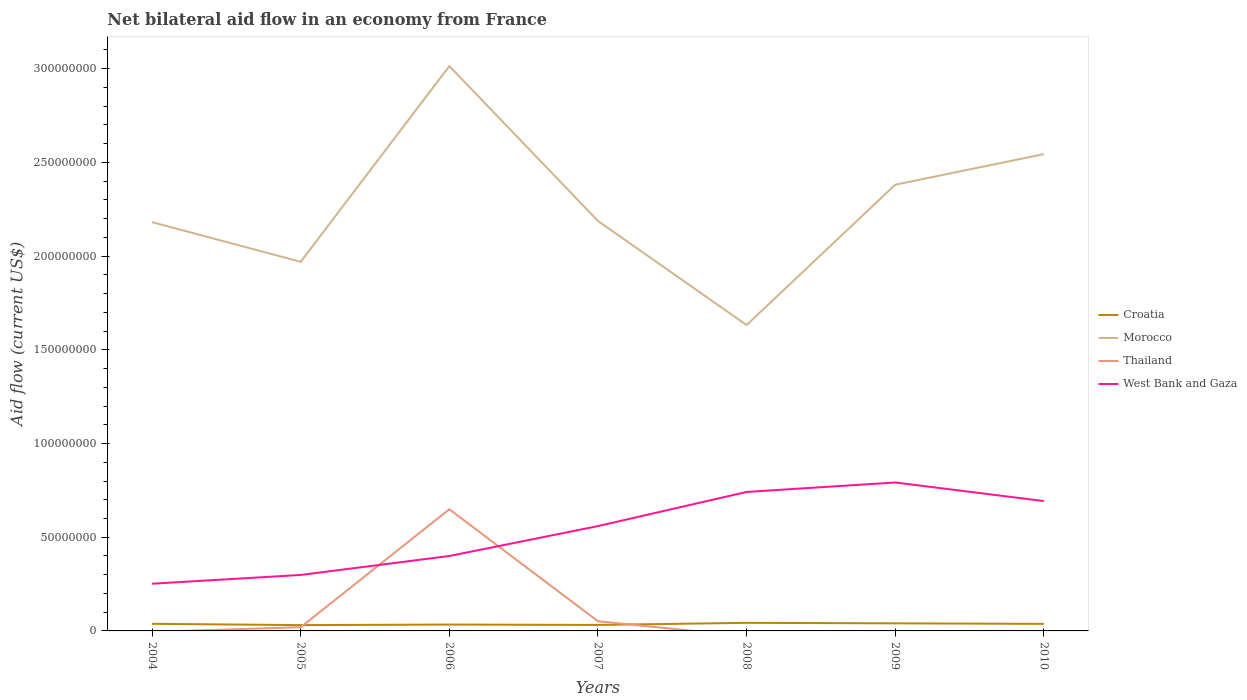How many different coloured lines are there?
Provide a succinct answer. 4. Does the line corresponding to West Bank and Gaza intersect with the line corresponding to Croatia?
Offer a terse response. No. Across all years, what is the maximum net bilateral aid flow in West Bank and Gaza?
Make the answer very short. 2.52e+07. What is the total net bilateral aid flow in West Bank and Gaza in the graph?
Ensure brevity in your answer.  -4.68e+06. What is the difference between the highest and the second highest net bilateral aid flow in Croatia?
Make the answer very short. 1.22e+06. How many years are there in the graph?
Provide a succinct answer. 7. What is the difference between two consecutive major ticks on the Y-axis?
Provide a succinct answer. 5.00e+07. Where does the legend appear in the graph?
Offer a terse response. Center right. What is the title of the graph?
Your answer should be very brief. Net bilateral aid flow in an economy from France. What is the label or title of the X-axis?
Give a very brief answer. Years. What is the Aid flow (current US$) of Croatia in 2004?
Offer a terse response. 3.79e+06. What is the Aid flow (current US$) in Morocco in 2004?
Ensure brevity in your answer.  2.18e+08. What is the Aid flow (current US$) in West Bank and Gaza in 2004?
Ensure brevity in your answer.  2.52e+07. What is the Aid flow (current US$) in Croatia in 2005?
Make the answer very short. 3.10e+06. What is the Aid flow (current US$) of Morocco in 2005?
Your answer should be very brief. 1.97e+08. What is the Aid flow (current US$) of Thailand in 2005?
Offer a terse response. 1.99e+06. What is the Aid flow (current US$) in West Bank and Gaza in 2005?
Your response must be concise. 2.99e+07. What is the Aid flow (current US$) in Croatia in 2006?
Offer a terse response. 3.39e+06. What is the Aid flow (current US$) in Morocco in 2006?
Your answer should be compact. 3.01e+08. What is the Aid flow (current US$) of Thailand in 2006?
Provide a succinct answer. 6.49e+07. What is the Aid flow (current US$) in West Bank and Gaza in 2006?
Your response must be concise. 4.00e+07. What is the Aid flow (current US$) of Croatia in 2007?
Your answer should be very brief. 3.19e+06. What is the Aid flow (current US$) in Morocco in 2007?
Your response must be concise. 2.19e+08. What is the Aid flow (current US$) of Thailand in 2007?
Give a very brief answer. 5.16e+06. What is the Aid flow (current US$) in West Bank and Gaza in 2007?
Your answer should be compact. 5.59e+07. What is the Aid flow (current US$) of Croatia in 2008?
Ensure brevity in your answer.  4.32e+06. What is the Aid flow (current US$) of Morocco in 2008?
Ensure brevity in your answer.  1.63e+08. What is the Aid flow (current US$) in Thailand in 2008?
Make the answer very short. 0. What is the Aid flow (current US$) in West Bank and Gaza in 2008?
Your answer should be compact. 7.42e+07. What is the Aid flow (current US$) of Croatia in 2009?
Give a very brief answer. 4.04e+06. What is the Aid flow (current US$) in Morocco in 2009?
Your answer should be compact. 2.38e+08. What is the Aid flow (current US$) in West Bank and Gaza in 2009?
Offer a terse response. 7.92e+07. What is the Aid flow (current US$) of Croatia in 2010?
Your response must be concise. 3.77e+06. What is the Aid flow (current US$) of Morocco in 2010?
Provide a short and direct response. 2.54e+08. What is the Aid flow (current US$) in Thailand in 2010?
Offer a terse response. 0. What is the Aid flow (current US$) in West Bank and Gaza in 2010?
Give a very brief answer. 6.93e+07. Across all years, what is the maximum Aid flow (current US$) in Croatia?
Keep it short and to the point. 4.32e+06. Across all years, what is the maximum Aid flow (current US$) in Morocco?
Keep it short and to the point. 3.01e+08. Across all years, what is the maximum Aid flow (current US$) in Thailand?
Your answer should be very brief. 6.49e+07. Across all years, what is the maximum Aid flow (current US$) of West Bank and Gaza?
Provide a succinct answer. 7.92e+07. Across all years, what is the minimum Aid flow (current US$) of Croatia?
Your answer should be compact. 3.10e+06. Across all years, what is the minimum Aid flow (current US$) of Morocco?
Keep it short and to the point. 1.63e+08. Across all years, what is the minimum Aid flow (current US$) in West Bank and Gaza?
Offer a terse response. 2.52e+07. What is the total Aid flow (current US$) of Croatia in the graph?
Make the answer very short. 2.56e+07. What is the total Aid flow (current US$) in Morocco in the graph?
Your answer should be compact. 1.59e+09. What is the total Aid flow (current US$) in Thailand in the graph?
Offer a terse response. 7.21e+07. What is the total Aid flow (current US$) of West Bank and Gaza in the graph?
Give a very brief answer. 3.74e+08. What is the difference between the Aid flow (current US$) of Croatia in 2004 and that in 2005?
Make the answer very short. 6.90e+05. What is the difference between the Aid flow (current US$) in Morocco in 2004 and that in 2005?
Your answer should be very brief. 2.11e+07. What is the difference between the Aid flow (current US$) in West Bank and Gaza in 2004 and that in 2005?
Offer a very short reply. -4.68e+06. What is the difference between the Aid flow (current US$) in Morocco in 2004 and that in 2006?
Give a very brief answer. -8.33e+07. What is the difference between the Aid flow (current US$) in West Bank and Gaza in 2004 and that in 2006?
Your response must be concise. -1.48e+07. What is the difference between the Aid flow (current US$) in Croatia in 2004 and that in 2007?
Ensure brevity in your answer.  6.00e+05. What is the difference between the Aid flow (current US$) in Morocco in 2004 and that in 2007?
Ensure brevity in your answer.  -6.50e+05. What is the difference between the Aid flow (current US$) of West Bank and Gaza in 2004 and that in 2007?
Your response must be concise. -3.07e+07. What is the difference between the Aid flow (current US$) in Croatia in 2004 and that in 2008?
Give a very brief answer. -5.30e+05. What is the difference between the Aid flow (current US$) in Morocco in 2004 and that in 2008?
Offer a terse response. 5.49e+07. What is the difference between the Aid flow (current US$) in West Bank and Gaza in 2004 and that in 2008?
Offer a terse response. -4.90e+07. What is the difference between the Aid flow (current US$) of Morocco in 2004 and that in 2009?
Provide a short and direct response. -2.00e+07. What is the difference between the Aid flow (current US$) in West Bank and Gaza in 2004 and that in 2009?
Your answer should be compact. -5.40e+07. What is the difference between the Aid flow (current US$) of Morocco in 2004 and that in 2010?
Ensure brevity in your answer.  -3.63e+07. What is the difference between the Aid flow (current US$) of West Bank and Gaza in 2004 and that in 2010?
Offer a very short reply. -4.41e+07. What is the difference between the Aid flow (current US$) of Morocco in 2005 and that in 2006?
Your response must be concise. -1.04e+08. What is the difference between the Aid flow (current US$) in Thailand in 2005 and that in 2006?
Ensure brevity in your answer.  -6.29e+07. What is the difference between the Aid flow (current US$) in West Bank and Gaza in 2005 and that in 2006?
Give a very brief answer. -1.01e+07. What is the difference between the Aid flow (current US$) of Morocco in 2005 and that in 2007?
Ensure brevity in your answer.  -2.18e+07. What is the difference between the Aid flow (current US$) of Thailand in 2005 and that in 2007?
Offer a terse response. -3.17e+06. What is the difference between the Aid flow (current US$) of West Bank and Gaza in 2005 and that in 2007?
Your answer should be compact. -2.61e+07. What is the difference between the Aid flow (current US$) of Croatia in 2005 and that in 2008?
Your answer should be very brief. -1.22e+06. What is the difference between the Aid flow (current US$) in Morocco in 2005 and that in 2008?
Make the answer very short. 3.38e+07. What is the difference between the Aid flow (current US$) of West Bank and Gaza in 2005 and that in 2008?
Your answer should be very brief. -4.43e+07. What is the difference between the Aid flow (current US$) in Croatia in 2005 and that in 2009?
Your response must be concise. -9.40e+05. What is the difference between the Aid flow (current US$) of Morocco in 2005 and that in 2009?
Provide a succinct answer. -4.11e+07. What is the difference between the Aid flow (current US$) of West Bank and Gaza in 2005 and that in 2009?
Ensure brevity in your answer.  -4.93e+07. What is the difference between the Aid flow (current US$) in Croatia in 2005 and that in 2010?
Provide a succinct answer. -6.70e+05. What is the difference between the Aid flow (current US$) of Morocco in 2005 and that in 2010?
Provide a succinct answer. -5.74e+07. What is the difference between the Aid flow (current US$) in West Bank and Gaza in 2005 and that in 2010?
Provide a short and direct response. -3.94e+07. What is the difference between the Aid flow (current US$) in Morocco in 2006 and that in 2007?
Your response must be concise. 8.26e+07. What is the difference between the Aid flow (current US$) of Thailand in 2006 and that in 2007?
Keep it short and to the point. 5.98e+07. What is the difference between the Aid flow (current US$) of West Bank and Gaza in 2006 and that in 2007?
Give a very brief answer. -1.60e+07. What is the difference between the Aid flow (current US$) of Croatia in 2006 and that in 2008?
Ensure brevity in your answer.  -9.30e+05. What is the difference between the Aid flow (current US$) of Morocco in 2006 and that in 2008?
Offer a very short reply. 1.38e+08. What is the difference between the Aid flow (current US$) in West Bank and Gaza in 2006 and that in 2008?
Ensure brevity in your answer.  -3.42e+07. What is the difference between the Aid flow (current US$) of Croatia in 2006 and that in 2009?
Offer a very short reply. -6.50e+05. What is the difference between the Aid flow (current US$) in Morocco in 2006 and that in 2009?
Your answer should be compact. 6.33e+07. What is the difference between the Aid flow (current US$) in West Bank and Gaza in 2006 and that in 2009?
Keep it short and to the point. -3.92e+07. What is the difference between the Aid flow (current US$) of Croatia in 2006 and that in 2010?
Offer a terse response. -3.80e+05. What is the difference between the Aid flow (current US$) in Morocco in 2006 and that in 2010?
Provide a succinct answer. 4.70e+07. What is the difference between the Aid flow (current US$) in West Bank and Gaza in 2006 and that in 2010?
Offer a terse response. -2.93e+07. What is the difference between the Aid flow (current US$) in Croatia in 2007 and that in 2008?
Your answer should be very brief. -1.13e+06. What is the difference between the Aid flow (current US$) of Morocco in 2007 and that in 2008?
Ensure brevity in your answer.  5.56e+07. What is the difference between the Aid flow (current US$) of West Bank and Gaza in 2007 and that in 2008?
Your answer should be very brief. -1.82e+07. What is the difference between the Aid flow (current US$) in Croatia in 2007 and that in 2009?
Provide a short and direct response. -8.50e+05. What is the difference between the Aid flow (current US$) of Morocco in 2007 and that in 2009?
Offer a very short reply. -1.93e+07. What is the difference between the Aid flow (current US$) in West Bank and Gaza in 2007 and that in 2009?
Keep it short and to the point. -2.33e+07. What is the difference between the Aid flow (current US$) in Croatia in 2007 and that in 2010?
Ensure brevity in your answer.  -5.80e+05. What is the difference between the Aid flow (current US$) of Morocco in 2007 and that in 2010?
Your response must be concise. -3.57e+07. What is the difference between the Aid flow (current US$) in West Bank and Gaza in 2007 and that in 2010?
Offer a terse response. -1.34e+07. What is the difference between the Aid flow (current US$) of Morocco in 2008 and that in 2009?
Ensure brevity in your answer.  -7.49e+07. What is the difference between the Aid flow (current US$) of West Bank and Gaza in 2008 and that in 2009?
Provide a short and direct response. -5.05e+06. What is the difference between the Aid flow (current US$) in Croatia in 2008 and that in 2010?
Your response must be concise. 5.50e+05. What is the difference between the Aid flow (current US$) of Morocco in 2008 and that in 2010?
Your answer should be compact. -9.12e+07. What is the difference between the Aid flow (current US$) of West Bank and Gaza in 2008 and that in 2010?
Provide a succinct answer. 4.87e+06. What is the difference between the Aid flow (current US$) of Morocco in 2009 and that in 2010?
Keep it short and to the point. -1.63e+07. What is the difference between the Aid flow (current US$) of West Bank and Gaza in 2009 and that in 2010?
Your answer should be compact. 9.92e+06. What is the difference between the Aid flow (current US$) in Croatia in 2004 and the Aid flow (current US$) in Morocco in 2005?
Provide a short and direct response. -1.93e+08. What is the difference between the Aid flow (current US$) of Croatia in 2004 and the Aid flow (current US$) of Thailand in 2005?
Provide a short and direct response. 1.80e+06. What is the difference between the Aid flow (current US$) of Croatia in 2004 and the Aid flow (current US$) of West Bank and Gaza in 2005?
Make the answer very short. -2.61e+07. What is the difference between the Aid flow (current US$) of Morocco in 2004 and the Aid flow (current US$) of Thailand in 2005?
Offer a very short reply. 2.16e+08. What is the difference between the Aid flow (current US$) of Morocco in 2004 and the Aid flow (current US$) of West Bank and Gaza in 2005?
Give a very brief answer. 1.88e+08. What is the difference between the Aid flow (current US$) in Croatia in 2004 and the Aid flow (current US$) in Morocco in 2006?
Provide a short and direct response. -2.98e+08. What is the difference between the Aid flow (current US$) in Croatia in 2004 and the Aid flow (current US$) in Thailand in 2006?
Give a very brief answer. -6.11e+07. What is the difference between the Aid flow (current US$) in Croatia in 2004 and the Aid flow (current US$) in West Bank and Gaza in 2006?
Make the answer very short. -3.62e+07. What is the difference between the Aid flow (current US$) of Morocco in 2004 and the Aid flow (current US$) of Thailand in 2006?
Your answer should be very brief. 1.53e+08. What is the difference between the Aid flow (current US$) in Morocco in 2004 and the Aid flow (current US$) in West Bank and Gaza in 2006?
Ensure brevity in your answer.  1.78e+08. What is the difference between the Aid flow (current US$) of Croatia in 2004 and the Aid flow (current US$) of Morocco in 2007?
Provide a short and direct response. -2.15e+08. What is the difference between the Aid flow (current US$) of Croatia in 2004 and the Aid flow (current US$) of Thailand in 2007?
Your response must be concise. -1.37e+06. What is the difference between the Aid flow (current US$) in Croatia in 2004 and the Aid flow (current US$) in West Bank and Gaza in 2007?
Your answer should be very brief. -5.21e+07. What is the difference between the Aid flow (current US$) in Morocco in 2004 and the Aid flow (current US$) in Thailand in 2007?
Your answer should be very brief. 2.13e+08. What is the difference between the Aid flow (current US$) of Morocco in 2004 and the Aid flow (current US$) of West Bank and Gaza in 2007?
Your answer should be compact. 1.62e+08. What is the difference between the Aid flow (current US$) of Croatia in 2004 and the Aid flow (current US$) of Morocco in 2008?
Ensure brevity in your answer.  -1.59e+08. What is the difference between the Aid flow (current US$) of Croatia in 2004 and the Aid flow (current US$) of West Bank and Gaza in 2008?
Your response must be concise. -7.04e+07. What is the difference between the Aid flow (current US$) of Morocco in 2004 and the Aid flow (current US$) of West Bank and Gaza in 2008?
Ensure brevity in your answer.  1.44e+08. What is the difference between the Aid flow (current US$) in Croatia in 2004 and the Aid flow (current US$) in Morocco in 2009?
Offer a very short reply. -2.34e+08. What is the difference between the Aid flow (current US$) of Croatia in 2004 and the Aid flow (current US$) of West Bank and Gaza in 2009?
Offer a terse response. -7.54e+07. What is the difference between the Aid flow (current US$) of Morocco in 2004 and the Aid flow (current US$) of West Bank and Gaza in 2009?
Provide a succinct answer. 1.39e+08. What is the difference between the Aid flow (current US$) in Croatia in 2004 and the Aid flow (current US$) in Morocco in 2010?
Provide a short and direct response. -2.51e+08. What is the difference between the Aid flow (current US$) in Croatia in 2004 and the Aid flow (current US$) in West Bank and Gaza in 2010?
Keep it short and to the point. -6.55e+07. What is the difference between the Aid flow (current US$) of Morocco in 2004 and the Aid flow (current US$) of West Bank and Gaza in 2010?
Give a very brief answer. 1.49e+08. What is the difference between the Aid flow (current US$) of Croatia in 2005 and the Aid flow (current US$) of Morocco in 2006?
Give a very brief answer. -2.98e+08. What is the difference between the Aid flow (current US$) in Croatia in 2005 and the Aid flow (current US$) in Thailand in 2006?
Offer a terse response. -6.18e+07. What is the difference between the Aid flow (current US$) of Croatia in 2005 and the Aid flow (current US$) of West Bank and Gaza in 2006?
Ensure brevity in your answer.  -3.69e+07. What is the difference between the Aid flow (current US$) of Morocco in 2005 and the Aid flow (current US$) of Thailand in 2006?
Provide a short and direct response. 1.32e+08. What is the difference between the Aid flow (current US$) in Morocco in 2005 and the Aid flow (current US$) in West Bank and Gaza in 2006?
Ensure brevity in your answer.  1.57e+08. What is the difference between the Aid flow (current US$) of Thailand in 2005 and the Aid flow (current US$) of West Bank and Gaza in 2006?
Make the answer very short. -3.80e+07. What is the difference between the Aid flow (current US$) in Croatia in 2005 and the Aid flow (current US$) in Morocco in 2007?
Your answer should be very brief. -2.16e+08. What is the difference between the Aid flow (current US$) in Croatia in 2005 and the Aid flow (current US$) in Thailand in 2007?
Your answer should be compact. -2.06e+06. What is the difference between the Aid flow (current US$) in Croatia in 2005 and the Aid flow (current US$) in West Bank and Gaza in 2007?
Your answer should be compact. -5.28e+07. What is the difference between the Aid flow (current US$) in Morocco in 2005 and the Aid flow (current US$) in Thailand in 2007?
Your answer should be very brief. 1.92e+08. What is the difference between the Aid flow (current US$) of Morocco in 2005 and the Aid flow (current US$) of West Bank and Gaza in 2007?
Your response must be concise. 1.41e+08. What is the difference between the Aid flow (current US$) of Thailand in 2005 and the Aid flow (current US$) of West Bank and Gaza in 2007?
Ensure brevity in your answer.  -5.39e+07. What is the difference between the Aid flow (current US$) in Croatia in 2005 and the Aid flow (current US$) in Morocco in 2008?
Give a very brief answer. -1.60e+08. What is the difference between the Aid flow (current US$) of Croatia in 2005 and the Aid flow (current US$) of West Bank and Gaza in 2008?
Give a very brief answer. -7.11e+07. What is the difference between the Aid flow (current US$) of Morocco in 2005 and the Aid flow (current US$) of West Bank and Gaza in 2008?
Your answer should be very brief. 1.23e+08. What is the difference between the Aid flow (current US$) of Thailand in 2005 and the Aid flow (current US$) of West Bank and Gaza in 2008?
Provide a short and direct response. -7.22e+07. What is the difference between the Aid flow (current US$) in Croatia in 2005 and the Aid flow (current US$) in Morocco in 2009?
Keep it short and to the point. -2.35e+08. What is the difference between the Aid flow (current US$) in Croatia in 2005 and the Aid flow (current US$) in West Bank and Gaza in 2009?
Your answer should be compact. -7.61e+07. What is the difference between the Aid flow (current US$) in Morocco in 2005 and the Aid flow (current US$) in West Bank and Gaza in 2009?
Give a very brief answer. 1.18e+08. What is the difference between the Aid flow (current US$) of Thailand in 2005 and the Aid flow (current US$) of West Bank and Gaza in 2009?
Give a very brief answer. -7.72e+07. What is the difference between the Aid flow (current US$) of Croatia in 2005 and the Aid flow (current US$) of Morocco in 2010?
Ensure brevity in your answer.  -2.51e+08. What is the difference between the Aid flow (current US$) in Croatia in 2005 and the Aid flow (current US$) in West Bank and Gaza in 2010?
Ensure brevity in your answer.  -6.62e+07. What is the difference between the Aid flow (current US$) in Morocco in 2005 and the Aid flow (current US$) in West Bank and Gaza in 2010?
Give a very brief answer. 1.28e+08. What is the difference between the Aid flow (current US$) of Thailand in 2005 and the Aid flow (current US$) of West Bank and Gaza in 2010?
Provide a short and direct response. -6.73e+07. What is the difference between the Aid flow (current US$) in Croatia in 2006 and the Aid flow (current US$) in Morocco in 2007?
Keep it short and to the point. -2.15e+08. What is the difference between the Aid flow (current US$) of Croatia in 2006 and the Aid flow (current US$) of Thailand in 2007?
Your answer should be very brief. -1.77e+06. What is the difference between the Aid flow (current US$) in Croatia in 2006 and the Aid flow (current US$) in West Bank and Gaza in 2007?
Keep it short and to the point. -5.25e+07. What is the difference between the Aid flow (current US$) of Morocco in 2006 and the Aid flow (current US$) of Thailand in 2007?
Ensure brevity in your answer.  2.96e+08. What is the difference between the Aid flow (current US$) in Morocco in 2006 and the Aid flow (current US$) in West Bank and Gaza in 2007?
Your answer should be compact. 2.45e+08. What is the difference between the Aid flow (current US$) in Thailand in 2006 and the Aid flow (current US$) in West Bank and Gaza in 2007?
Provide a succinct answer. 8.99e+06. What is the difference between the Aid flow (current US$) of Croatia in 2006 and the Aid flow (current US$) of Morocco in 2008?
Keep it short and to the point. -1.60e+08. What is the difference between the Aid flow (current US$) of Croatia in 2006 and the Aid flow (current US$) of West Bank and Gaza in 2008?
Your response must be concise. -7.08e+07. What is the difference between the Aid flow (current US$) of Morocco in 2006 and the Aid flow (current US$) of West Bank and Gaza in 2008?
Keep it short and to the point. 2.27e+08. What is the difference between the Aid flow (current US$) of Thailand in 2006 and the Aid flow (current US$) of West Bank and Gaza in 2008?
Your answer should be compact. -9.24e+06. What is the difference between the Aid flow (current US$) in Croatia in 2006 and the Aid flow (current US$) in Morocco in 2009?
Provide a short and direct response. -2.35e+08. What is the difference between the Aid flow (current US$) of Croatia in 2006 and the Aid flow (current US$) of West Bank and Gaza in 2009?
Ensure brevity in your answer.  -7.58e+07. What is the difference between the Aid flow (current US$) of Morocco in 2006 and the Aid flow (current US$) of West Bank and Gaza in 2009?
Keep it short and to the point. 2.22e+08. What is the difference between the Aid flow (current US$) of Thailand in 2006 and the Aid flow (current US$) of West Bank and Gaza in 2009?
Make the answer very short. -1.43e+07. What is the difference between the Aid flow (current US$) of Croatia in 2006 and the Aid flow (current US$) of Morocco in 2010?
Make the answer very short. -2.51e+08. What is the difference between the Aid flow (current US$) of Croatia in 2006 and the Aid flow (current US$) of West Bank and Gaza in 2010?
Provide a succinct answer. -6.59e+07. What is the difference between the Aid flow (current US$) in Morocco in 2006 and the Aid flow (current US$) in West Bank and Gaza in 2010?
Your response must be concise. 2.32e+08. What is the difference between the Aid flow (current US$) of Thailand in 2006 and the Aid flow (current US$) of West Bank and Gaza in 2010?
Offer a very short reply. -4.37e+06. What is the difference between the Aid flow (current US$) in Croatia in 2007 and the Aid flow (current US$) in Morocco in 2008?
Make the answer very short. -1.60e+08. What is the difference between the Aid flow (current US$) of Croatia in 2007 and the Aid flow (current US$) of West Bank and Gaza in 2008?
Ensure brevity in your answer.  -7.10e+07. What is the difference between the Aid flow (current US$) in Morocco in 2007 and the Aid flow (current US$) in West Bank and Gaza in 2008?
Offer a very short reply. 1.45e+08. What is the difference between the Aid flow (current US$) of Thailand in 2007 and the Aid flow (current US$) of West Bank and Gaza in 2008?
Offer a terse response. -6.90e+07. What is the difference between the Aid flow (current US$) of Croatia in 2007 and the Aid flow (current US$) of Morocco in 2009?
Your answer should be very brief. -2.35e+08. What is the difference between the Aid flow (current US$) in Croatia in 2007 and the Aid flow (current US$) in West Bank and Gaza in 2009?
Your answer should be very brief. -7.60e+07. What is the difference between the Aid flow (current US$) in Morocco in 2007 and the Aid flow (current US$) in West Bank and Gaza in 2009?
Provide a short and direct response. 1.40e+08. What is the difference between the Aid flow (current US$) in Thailand in 2007 and the Aid flow (current US$) in West Bank and Gaza in 2009?
Your answer should be compact. -7.40e+07. What is the difference between the Aid flow (current US$) of Croatia in 2007 and the Aid flow (current US$) of Morocco in 2010?
Keep it short and to the point. -2.51e+08. What is the difference between the Aid flow (current US$) in Croatia in 2007 and the Aid flow (current US$) in West Bank and Gaza in 2010?
Offer a terse response. -6.61e+07. What is the difference between the Aid flow (current US$) in Morocco in 2007 and the Aid flow (current US$) in West Bank and Gaza in 2010?
Your answer should be compact. 1.49e+08. What is the difference between the Aid flow (current US$) of Thailand in 2007 and the Aid flow (current US$) of West Bank and Gaza in 2010?
Your answer should be very brief. -6.41e+07. What is the difference between the Aid flow (current US$) in Croatia in 2008 and the Aid flow (current US$) in Morocco in 2009?
Give a very brief answer. -2.34e+08. What is the difference between the Aid flow (current US$) in Croatia in 2008 and the Aid flow (current US$) in West Bank and Gaza in 2009?
Your answer should be compact. -7.49e+07. What is the difference between the Aid flow (current US$) of Morocco in 2008 and the Aid flow (current US$) of West Bank and Gaza in 2009?
Your response must be concise. 8.40e+07. What is the difference between the Aid flow (current US$) in Croatia in 2008 and the Aid flow (current US$) in Morocco in 2010?
Offer a terse response. -2.50e+08. What is the difference between the Aid flow (current US$) of Croatia in 2008 and the Aid flow (current US$) of West Bank and Gaza in 2010?
Give a very brief answer. -6.50e+07. What is the difference between the Aid flow (current US$) of Morocco in 2008 and the Aid flow (current US$) of West Bank and Gaza in 2010?
Your answer should be compact. 9.39e+07. What is the difference between the Aid flow (current US$) in Croatia in 2009 and the Aid flow (current US$) in Morocco in 2010?
Provide a succinct answer. -2.50e+08. What is the difference between the Aid flow (current US$) of Croatia in 2009 and the Aid flow (current US$) of West Bank and Gaza in 2010?
Keep it short and to the point. -6.52e+07. What is the difference between the Aid flow (current US$) in Morocco in 2009 and the Aid flow (current US$) in West Bank and Gaza in 2010?
Provide a short and direct response. 1.69e+08. What is the average Aid flow (current US$) of Croatia per year?
Make the answer very short. 3.66e+06. What is the average Aid flow (current US$) of Morocco per year?
Your answer should be very brief. 2.27e+08. What is the average Aid flow (current US$) of Thailand per year?
Provide a short and direct response. 1.03e+07. What is the average Aid flow (current US$) of West Bank and Gaza per year?
Your answer should be compact. 5.34e+07. In the year 2004, what is the difference between the Aid flow (current US$) of Croatia and Aid flow (current US$) of Morocco?
Provide a short and direct response. -2.14e+08. In the year 2004, what is the difference between the Aid flow (current US$) in Croatia and Aid flow (current US$) in West Bank and Gaza?
Ensure brevity in your answer.  -2.14e+07. In the year 2004, what is the difference between the Aid flow (current US$) of Morocco and Aid flow (current US$) of West Bank and Gaza?
Provide a succinct answer. 1.93e+08. In the year 2005, what is the difference between the Aid flow (current US$) of Croatia and Aid flow (current US$) of Morocco?
Make the answer very short. -1.94e+08. In the year 2005, what is the difference between the Aid flow (current US$) in Croatia and Aid flow (current US$) in Thailand?
Your answer should be compact. 1.11e+06. In the year 2005, what is the difference between the Aid flow (current US$) in Croatia and Aid flow (current US$) in West Bank and Gaza?
Provide a succinct answer. -2.68e+07. In the year 2005, what is the difference between the Aid flow (current US$) in Morocco and Aid flow (current US$) in Thailand?
Keep it short and to the point. 1.95e+08. In the year 2005, what is the difference between the Aid flow (current US$) of Morocco and Aid flow (current US$) of West Bank and Gaza?
Keep it short and to the point. 1.67e+08. In the year 2005, what is the difference between the Aid flow (current US$) in Thailand and Aid flow (current US$) in West Bank and Gaza?
Keep it short and to the point. -2.79e+07. In the year 2006, what is the difference between the Aid flow (current US$) in Croatia and Aid flow (current US$) in Morocco?
Give a very brief answer. -2.98e+08. In the year 2006, what is the difference between the Aid flow (current US$) of Croatia and Aid flow (current US$) of Thailand?
Make the answer very short. -6.15e+07. In the year 2006, what is the difference between the Aid flow (current US$) in Croatia and Aid flow (current US$) in West Bank and Gaza?
Provide a succinct answer. -3.66e+07. In the year 2006, what is the difference between the Aid flow (current US$) in Morocco and Aid flow (current US$) in Thailand?
Provide a short and direct response. 2.36e+08. In the year 2006, what is the difference between the Aid flow (current US$) in Morocco and Aid flow (current US$) in West Bank and Gaza?
Your response must be concise. 2.61e+08. In the year 2006, what is the difference between the Aid flow (current US$) in Thailand and Aid flow (current US$) in West Bank and Gaza?
Your response must be concise. 2.49e+07. In the year 2007, what is the difference between the Aid flow (current US$) of Croatia and Aid flow (current US$) of Morocco?
Your response must be concise. -2.16e+08. In the year 2007, what is the difference between the Aid flow (current US$) in Croatia and Aid flow (current US$) in Thailand?
Offer a very short reply. -1.97e+06. In the year 2007, what is the difference between the Aid flow (current US$) in Croatia and Aid flow (current US$) in West Bank and Gaza?
Your answer should be compact. -5.27e+07. In the year 2007, what is the difference between the Aid flow (current US$) in Morocco and Aid flow (current US$) in Thailand?
Ensure brevity in your answer.  2.14e+08. In the year 2007, what is the difference between the Aid flow (current US$) in Morocco and Aid flow (current US$) in West Bank and Gaza?
Ensure brevity in your answer.  1.63e+08. In the year 2007, what is the difference between the Aid flow (current US$) in Thailand and Aid flow (current US$) in West Bank and Gaza?
Make the answer very short. -5.08e+07. In the year 2008, what is the difference between the Aid flow (current US$) of Croatia and Aid flow (current US$) of Morocco?
Your answer should be very brief. -1.59e+08. In the year 2008, what is the difference between the Aid flow (current US$) in Croatia and Aid flow (current US$) in West Bank and Gaza?
Make the answer very short. -6.98e+07. In the year 2008, what is the difference between the Aid flow (current US$) of Morocco and Aid flow (current US$) of West Bank and Gaza?
Provide a short and direct response. 8.90e+07. In the year 2009, what is the difference between the Aid flow (current US$) of Croatia and Aid flow (current US$) of Morocco?
Keep it short and to the point. -2.34e+08. In the year 2009, what is the difference between the Aid flow (current US$) in Croatia and Aid flow (current US$) in West Bank and Gaza?
Provide a short and direct response. -7.52e+07. In the year 2009, what is the difference between the Aid flow (current US$) of Morocco and Aid flow (current US$) of West Bank and Gaza?
Your answer should be very brief. 1.59e+08. In the year 2010, what is the difference between the Aid flow (current US$) in Croatia and Aid flow (current US$) in Morocco?
Your answer should be very brief. -2.51e+08. In the year 2010, what is the difference between the Aid flow (current US$) in Croatia and Aid flow (current US$) in West Bank and Gaza?
Offer a very short reply. -6.55e+07. In the year 2010, what is the difference between the Aid flow (current US$) of Morocco and Aid flow (current US$) of West Bank and Gaza?
Make the answer very short. 1.85e+08. What is the ratio of the Aid flow (current US$) of Croatia in 2004 to that in 2005?
Keep it short and to the point. 1.22. What is the ratio of the Aid flow (current US$) of Morocco in 2004 to that in 2005?
Provide a succinct answer. 1.11. What is the ratio of the Aid flow (current US$) in West Bank and Gaza in 2004 to that in 2005?
Offer a terse response. 0.84. What is the ratio of the Aid flow (current US$) of Croatia in 2004 to that in 2006?
Provide a succinct answer. 1.12. What is the ratio of the Aid flow (current US$) in Morocco in 2004 to that in 2006?
Your response must be concise. 0.72. What is the ratio of the Aid flow (current US$) of West Bank and Gaza in 2004 to that in 2006?
Your answer should be very brief. 0.63. What is the ratio of the Aid flow (current US$) of Croatia in 2004 to that in 2007?
Provide a short and direct response. 1.19. What is the ratio of the Aid flow (current US$) of West Bank and Gaza in 2004 to that in 2007?
Provide a succinct answer. 0.45. What is the ratio of the Aid flow (current US$) in Croatia in 2004 to that in 2008?
Offer a very short reply. 0.88. What is the ratio of the Aid flow (current US$) of Morocco in 2004 to that in 2008?
Keep it short and to the point. 1.34. What is the ratio of the Aid flow (current US$) in West Bank and Gaza in 2004 to that in 2008?
Keep it short and to the point. 0.34. What is the ratio of the Aid flow (current US$) of Croatia in 2004 to that in 2009?
Your answer should be very brief. 0.94. What is the ratio of the Aid flow (current US$) of Morocco in 2004 to that in 2009?
Your answer should be compact. 0.92. What is the ratio of the Aid flow (current US$) in West Bank and Gaza in 2004 to that in 2009?
Your answer should be compact. 0.32. What is the ratio of the Aid flow (current US$) in Morocco in 2004 to that in 2010?
Your answer should be compact. 0.86. What is the ratio of the Aid flow (current US$) of West Bank and Gaza in 2004 to that in 2010?
Keep it short and to the point. 0.36. What is the ratio of the Aid flow (current US$) of Croatia in 2005 to that in 2006?
Your answer should be very brief. 0.91. What is the ratio of the Aid flow (current US$) in Morocco in 2005 to that in 2006?
Offer a very short reply. 0.65. What is the ratio of the Aid flow (current US$) of Thailand in 2005 to that in 2006?
Give a very brief answer. 0.03. What is the ratio of the Aid flow (current US$) of West Bank and Gaza in 2005 to that in 2006?
Provide a short and direct response. 0.75. What is the ratio of the Aid flow (current US$) in Croatia in 2005 to that in 2007?
Ensure brevity in your answer.  0.97. What is the ratio of the Aid flow (current US$) of Morocco in 2005 to that in 2007?
Your response must be concise. 0.9. What is the ratio of the Aid flow (current US$) in Thailand in 2005 to that in 2007?
Offer a terse response. 0.39. What is the ratio of the Aid flow (current US$) in West Bank and Gaza in 2005 to that in 2007?
Keep it short and to the point. 0.53. What is the ratio of the Aid flow (current US$) of Croatia in 2005 to that in 2008?
Your response must be concise. 0.72. What is the ratio of the Aid flow (current US$) in Morocco in 2005 to that in 2008?
Provide a succinct answer. 1.21. What is the ratio of the Aid flow (current US$) of West Bank and Gaza in 2005 to that in 2008?
Your response must be concise. 0.4. What is the ratio of the Aid flow (current US$) in Croatia in 2005 to that in 2009?
Provide a succinct answer. 0.77. What is the ratio of the Aid flow (current US$) in Morocco in 2005 to that in 2009?
Your response must be concise. 0.83. What is the ratio of the Aid flow (current US$) in West Bank and Gaza in 2005 to that in 2009?
Keep it short and to the point. 0.38. What is the ratio of the Aid flow (current US$) in Croatia in 2005 to that in 2010?
Provide a short and direct response. 0.82. What is the ratio of the Aid flow (current US$) of Morocco in 2005 to that in 2010?
Your response must be concise. 0.77. What is the ratio of the Aid flow (current US$) in West Bank and Gaza in 2005 to that in 2010?
Make the answer very short. 0.43. What is the ratio of the Aid flow (current US$) of Croatia in 2006 to that in 2007?
Offer a very short reply. 1.06. What is the ratio of the Aid flow (current US$) in Morocco in 2006 to that in 2007?
Your answer should be compact. 1.38. What is the ratio of the Aid flow (current US$) in Thailand in 2006 to that in 2007?
Give a very brief answer. 12.58. What is the ratio of the Aid flow (current US$) of West Bank and Gaza in 2006 to that in 2007?
Your answer should be very brief. 0.71. What is the ratio of the Aid flow (current US$) of Croatia in 2006 to that in 2008?
Offer a very short reply. 0.78. What is the ratio of the Aid flow (current US$) of Morocco in 2006 to that in 2008?
Make the answer very short. 1.85. What is the ratio of the Aid flow (current US$) in West Bank and Gaza in 2006 to that in 2008?
Offer a terse response. 0.54. What is the ratio of the Aid flow (current US$) of Croatia in 2006 to that in 2009?
Offer a very short reply. 0.84. What is the ratio of the Aid flow (current US$) of Morocco in 2006 to that in 2009?
Ensure brevity in your answer.  1.27. What is the ratio of the Aid flow (current US$) in West Bank and Gaza in 2006 to that in 2009?
Ensure brevity in your answer.  0.5. What is the ratio of the Aid flow (current US$) in Croatia in 2006 to that in 2010?
Offer a terse response. 0.9. What is the ratio of the Aid flow (current US$) of Morocco in 2006 to that in 2010?
Your answer should be compact. 1.18. What is the ratio of the Aid flow (current US$) in West Bank and Gaza in 2006 to that in 2010?
Your answer should be very brief. 0.58. What is the ratio of the Aid flow (current US$) in Croatia in 2007 to that in 2008?
Provide a succinct answer. 0.74. What is the ratio of the Aid flow (current US$) of Morocco in 2007 to that in 2008?
Your answer should be compact. 1.34. What is the ratio of the Aid flow (current US$) in West Bank and Gaza in 2007 to that in 2008?
Give a very brief answer. 0.75. What is the ratio of the Aid flow (current US$) in Croatia in 2007 to that in 2009?
Provide a succinct answer. 0.79. What is the ratio of the Aid flow (current US$) in Morocco in 2007 to that in 2009?
Offer a very short reply. 0.92. What is the ratio of the Aid flow (current US$) of West Bank and Gaza in 2007 to that in 2009?
Give a very brief answer. 0.71. What is the ratio of the Aid flow (current US$) of Croatia in 2007 to that in 2010?
Ensure brevity in your answer.  0.85. What is the ratio of the Aid flow (current US$) in Morocco in 2007 to that in 2010?
Make the answer very short. 0.86. What is the ratio of the Aid flow (current US$) in West Bank and Gaza in 2007 to that in 2010?
Offer a very short reply. 0.81. What is the ratio of the Aid flow (current US$) in Croatia in 2008 to that in 2009?
Provide a short and direct response. 1.07. What is the ratio of the Aid flow (current US$) in Morocco in 2008 to that in 2009?
Offer a very short reply. 0.69. What is the ratio of the Aid flow (current US$) in West Bank and Gaza in 2008 to that in 2009?
Offer a very short reply. 0.94. What is the ratio of the Aid flow (current US$) in Croatia in 2008 to that in 2010?
Your response must be concise. 1.15. What is the ratio of the Aid flow (current US$) in Morocco in 2008 to that in 2010?
Make the answer very short. 0.64. What is the ratio of the Aid flow (current US$) of West Bank and Gaza in 2008 to that in 2010?
Keep it short and to the point. 1.07. What is the ratio of the Aid flow (current US$) of Croatia in 2009 to that in 2010?
Your answer should be compact. 1.07. What is the ratio of the Aid flow (current US$) in Morocco in 2009 to that in 2010?
Your response must be concise. 0.94. What is the ratio of the Aid flow (current US$) in West Bank and Gaza in 2009 to that in 2010?
Your answer should be compact. 1.14. What is the difference between the highest and the second highest Aid flow (current US$) of Morocco?
Your answer should be very brief. 4.70e+07. What is the difference between the highest and the second highest Aid flow (current US$) of Thailand?
Your answer should be compact. 5.98e+07. What is the difference between the highest and the second highest Aid flow (current US$) in West Bank and Gaza?
Offer a terse response. 5.05e+06. What is the difference between the highest and the lowest Aid flow (current US$) in Croatia?
Offer a terse response. 1.22e+06. What is the difference between the highest and the lowest Aid flow (current US$) in Morocco?
Provide a succinct answer. 1.38e+08. What is the difference between the highest and the lowest Aid flow (current US$) in Thailand?
Ensure brevity in your answer.  6.49e+07. What is the difference between the highest and the lowest Aid flow (current US$) of West Bank and Gaza?
Offer a very short reply. 5.40e+07. 